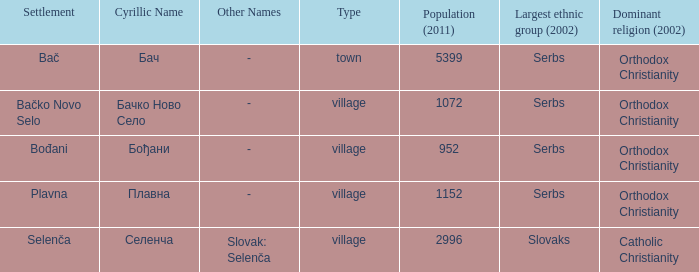How to you write  плавна with the latin alphabet? Plavna. 